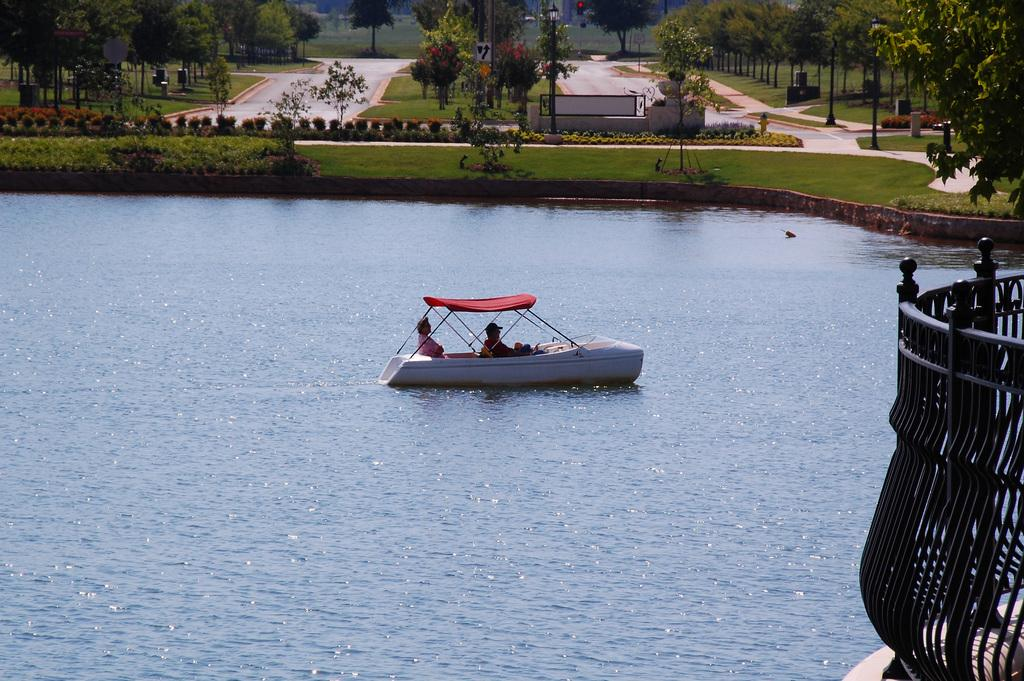What type of natural elements can be seen in the image? There are trees in the image. What man-made objects are present in the image? There are boards, a railing, and poles in the image. What activity is taking place in the image? There are people on a boat in the image. Are there any animals visible in the image? Yes, there is a bird on the water in the image. Where is the crate located in the image? There is no crate present in the image. How many people are in the crowd in the image? There is no crowd present in the image. 